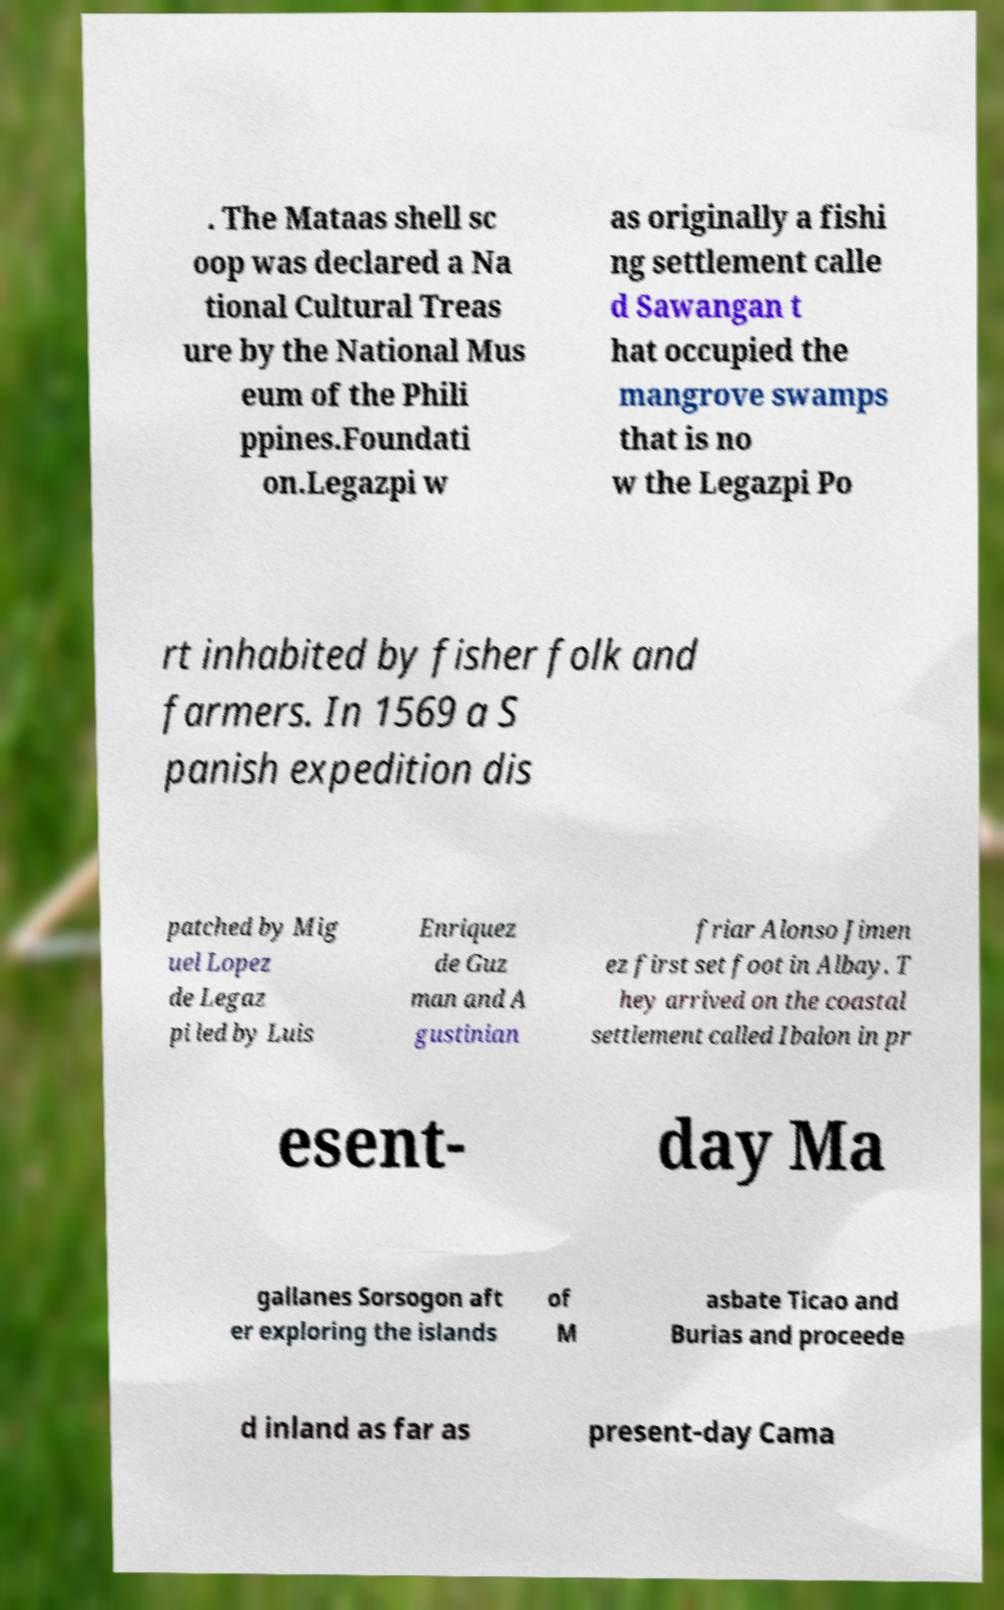I need the written content from this picture converted into text. Can you do that? . The Mataas shell sc oop was declared a Na tional Cultural Treas ure by the National Mus eum of the Phili ppines.Foundati on.Legazpi w as originally a fishi ng settlement calle d Sawangan t hat occupied the mangrove swamps that is no w the Legazpi Po rt inhabited by fisher folk and farmers. In 1569 a S panish expedition dis patched by Mig uel Lopez de Legaz pi led by Luis Enriquez de Guz man and A gustinian friar Alonso Jimen ez first set foot in Albay. T hey arrived on the coastal settlement called Ibalon in pr esent- day Ma gallanes Sorsogon aft er exploring the islands of M asbate Ticao and Burias and proceede d inland as far as present-day Cama 